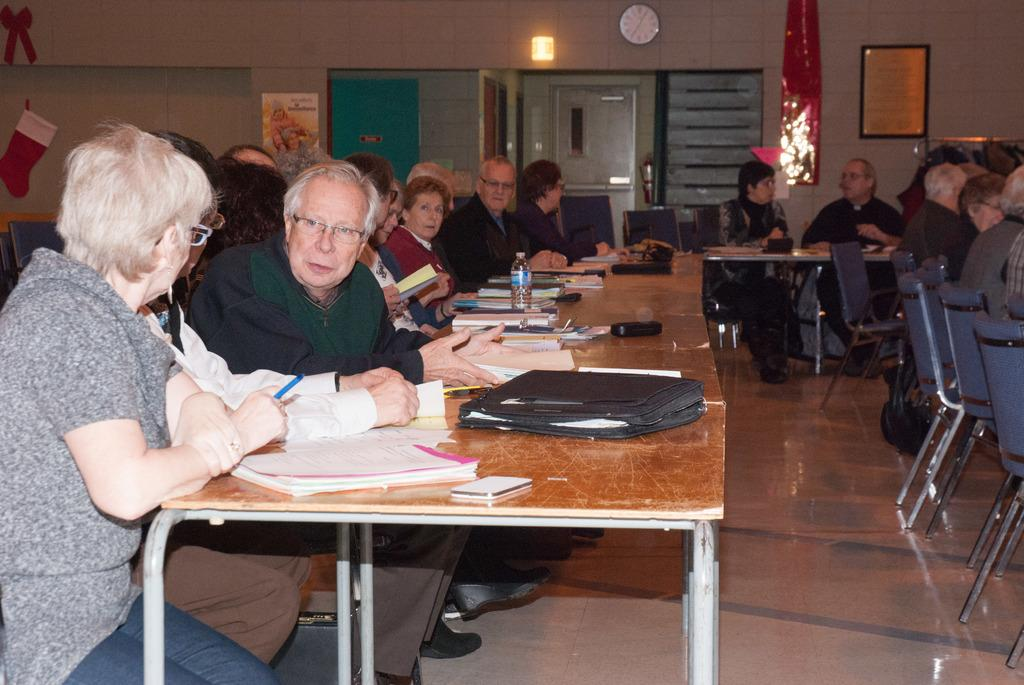What are the people in the image doing? The people in the image are sitting on chairs near a table. What objects can be seen on the table? There are books on the table. What can be seen in the background of the image? There is a light, a wall, a clock, and a door in the background. What type of harmony can be heard in the image? There is no audible harmony present in the image, as it is a still photograph. 